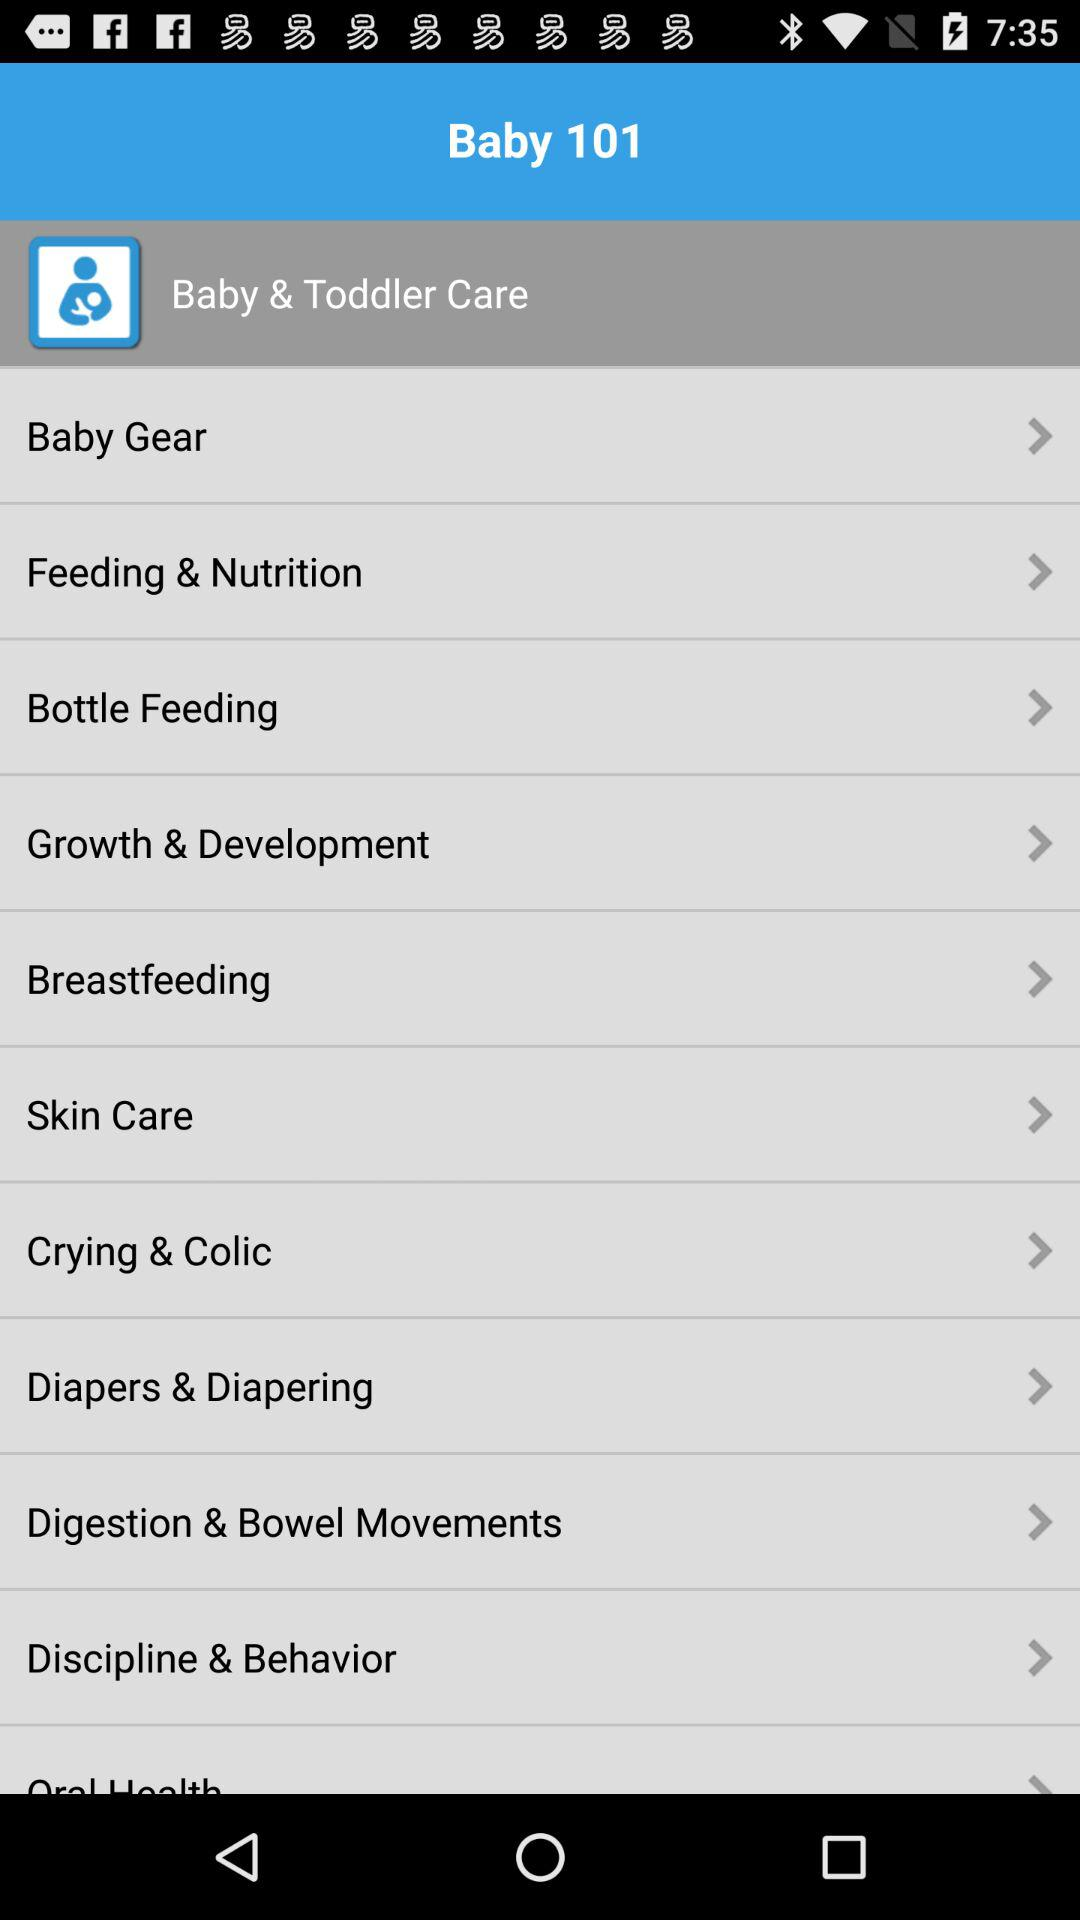What are the items listed in "Baby Gear"?
When the provided information is insufficient, respond with <no answer>. <no answer> 